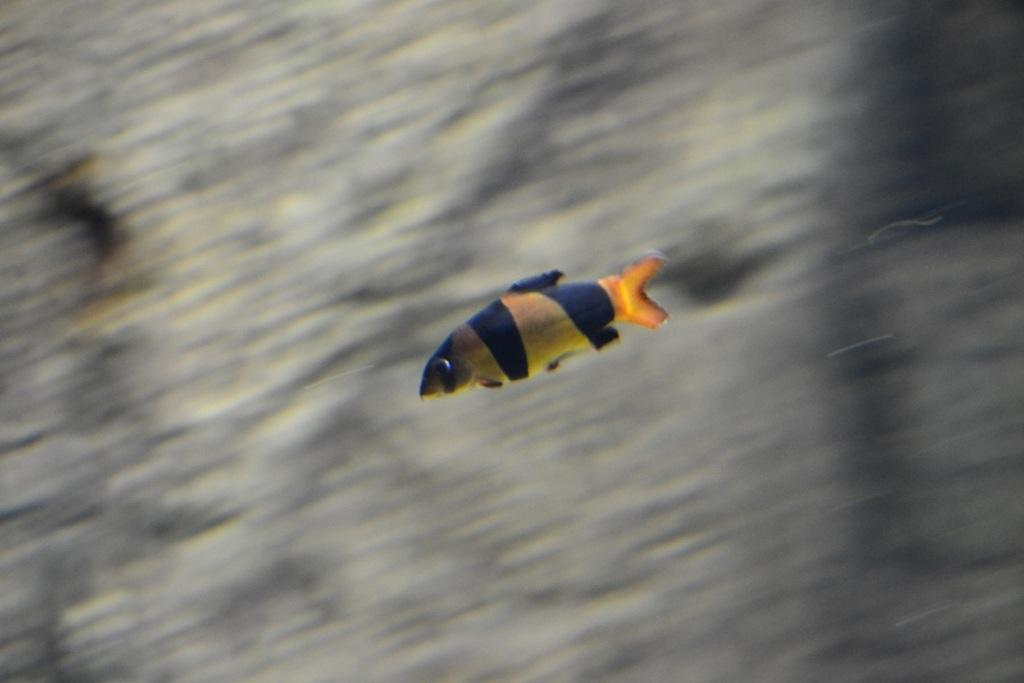What is the main subject of the image? There is a fish in the image. Can you describe the background of the image? The background of the image is blurred. What type of whip can be seen in the image? There is no whip present in the image; it features a fish with a blurred background. How many tomatoes are visible in the image? There are no tomatoes present in the image; it features a fish with a blurred background. 